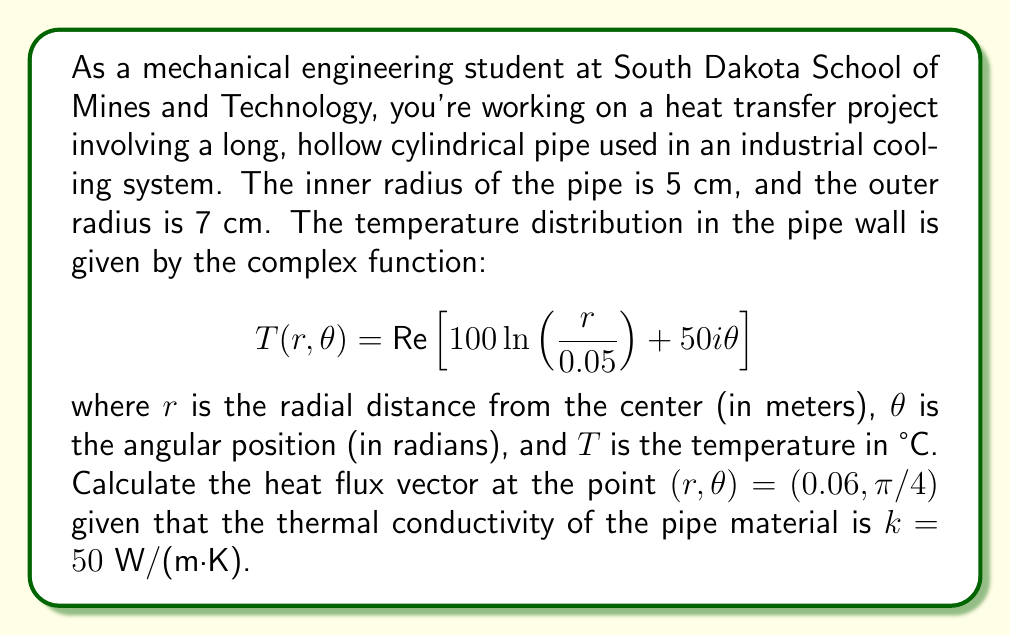Show me your answer to this math problem. To solve this problem, we'll follow these steps:

1) First, we need to express the temperature distribution in terms of its real part:
   $$T(r,\theta) = 100 \ln\left(\frac{r}{0.05}\right)$$

2) The heat flux vector in cylindrical coordinates is given by:
   $$\mathbf{q} = -k\left(\frac{\partial T}{\partial r}\hat{r} + \frac{1}{r}\frac{\partial T}{\partial \theta}\hat{\theta}\right)$$

3) Let's calculate the partial derivatives:
   $$\frac{\partial T}{\partial r} = \frac{100}{r}$$
   $$\frac{\partial T}{\partial \theta} = 0$$

4) Now we can substitute these into the heat flux equation:
   $$\mathbf{q} = -k\left(\frac{100}{r}\hat{r} + 0\hat{\theta}\right) = -\frac{100k}{r}\hat{r}$$

5) At the point $(r,\theta) = (0.06, \pi/4)$, we have:
   $$\mathbf{q} = -\frac{100 \cdot 50}{0.06}\hat{r} = -83333.33\hat{r} \text{ W/m}^2$$

6) To express this as a vector in cylindrical coordinates, we need to find the components:
   $$q_r = -83333.33 \text{ W/m}^2$$
   $$q_\theta = 0 \text{ W/m}^2$$

7) In vector notation:
   $$\mathbf{q} = -83333.33\hat{r} + 0\hat{\theta} \text{ W/m}^2$$

This is our final answer, representing the heat flux vector at the given point.
Answer: $$\mathbf{q} = -83333.33\hat{r} + 0\hat{\theta} \text{ W/m}^2$$ 